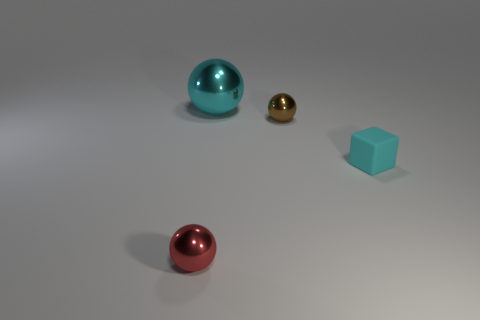Subtract all cyan spheres. Subtract all purple blocks. How many spheres are left? 2 Add 4 large cyan things. How many objects exist? 8 Subtract all balls. How many objects are left? 1 Subtract 0 yellow cubes. How many objects are left? 4 Subtract all large gray shiny objects. Subtract all cyan shiny balls. How many objects are left? 3 Add 3 small red spheres. How many small red spheres are left? 4 Add 4 brown shiny balls. How many brown shiny balls exist? 5 